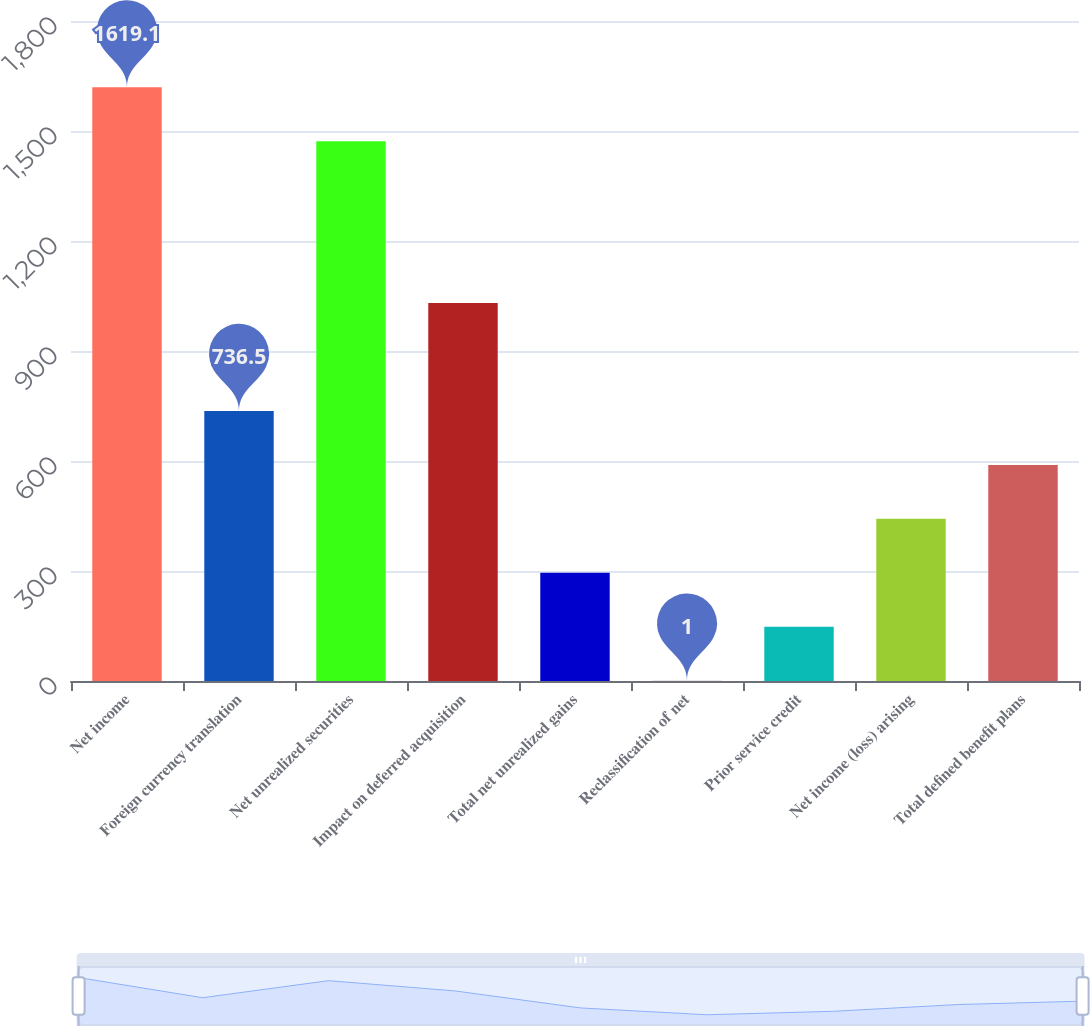<chart> <loc_0><loc_0><loc_500><loc_500><bar_chart><fcel>Net income<fcel>Foreign currency translation<fcel>Net unrealized securities<fcel>Impact on deferred acquisition<fcel>Total net unrealized gains<fcel>Reclassification of net<fcel>Prior service credit<fcel>Net income (loss) arising<fcel>Total defined benefit plans<nl><fcel>1619.1<fcel>736.5<fcel>1472<fcel>1030.7<fcel>295.2<fcel>1<fcel>148.1<fcel>442.3<fcel>589.4<nl></chart> 